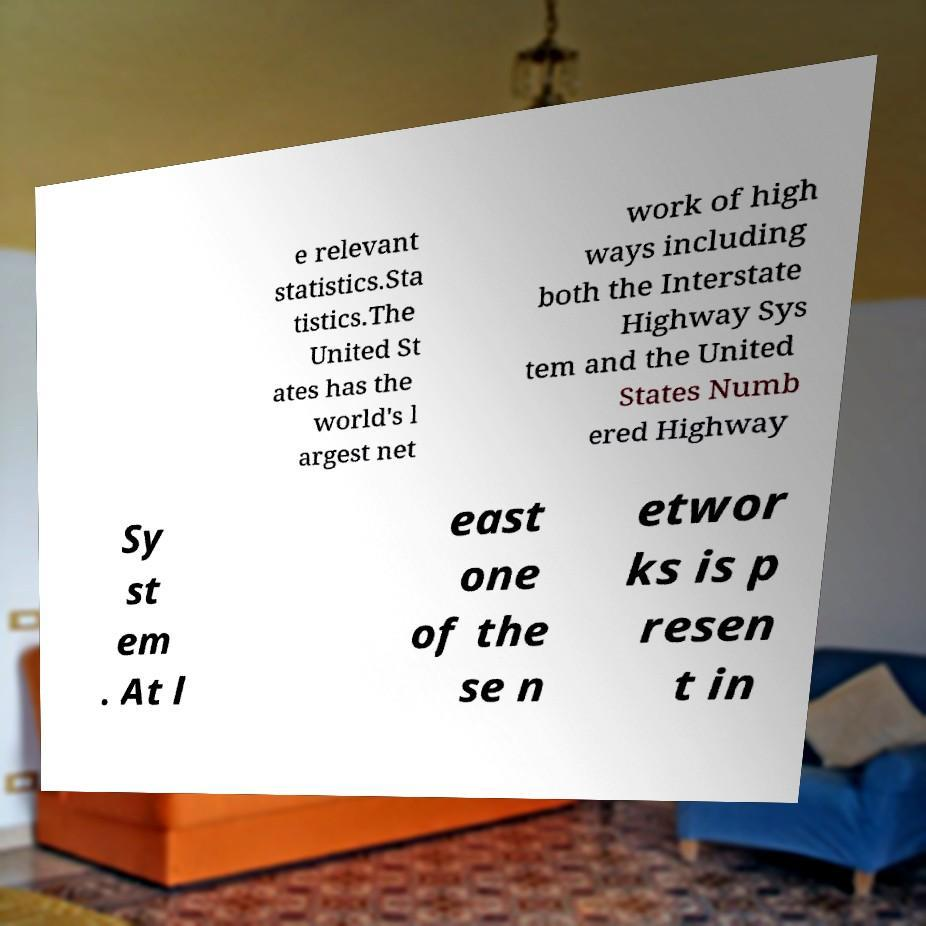Could you extract and type out the text from this image? e relevant statistics.Sta tistics.The United St ates has the world's l argest net work of high ways including both the Interstate Highway Sys tem and the United States Numb ered Highway Sy st em . At l east one of the se n etwor ks is p resen t in 